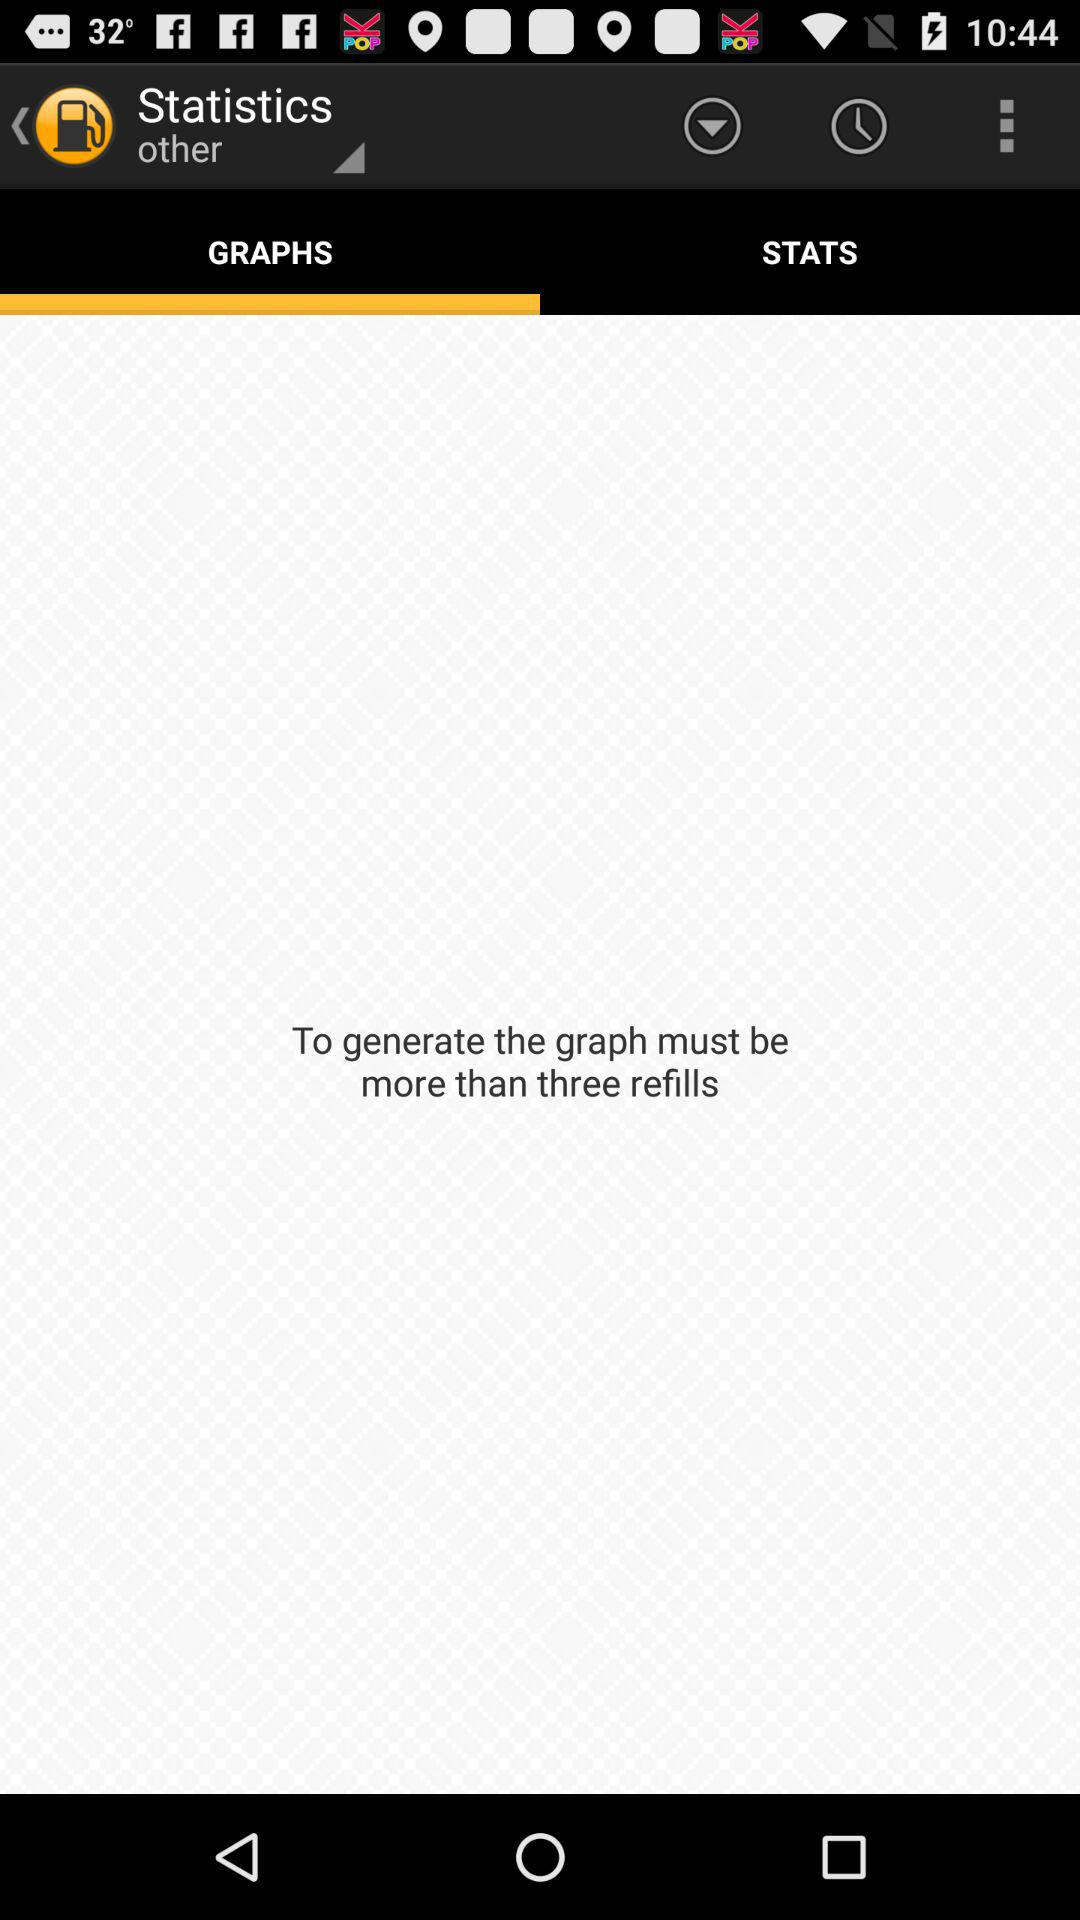How many refills are required to generate the graph? To generate the graph, more than three refills are required. 